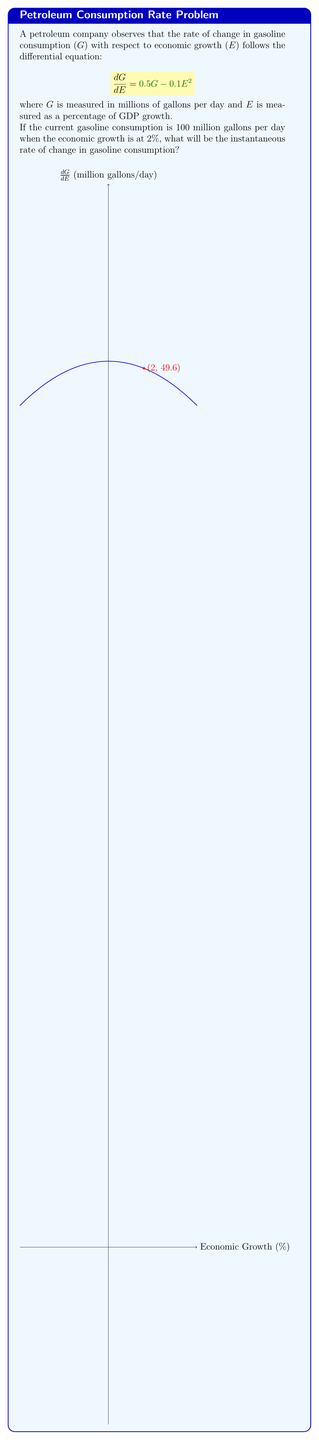Show me your answer to this math problem. To solve this problem, we need to follow these steps:

1) We are given the differential equation:
   $$\frac{dG}{dE} = 0.5G - 0.1E^2$$

2) We know that:
   G = 100 million gallons per day
   E = 2% GDP growth

3) To find the instantaneous rate of change, we need to substitute these values into the differential equation:

   $$\frac{dG}{dE} = 0.5(100) - 0.1(2^2)$$

4) Let's calculate step by step:
   
   $$\frac{dG}{dE} = 50 - 0.1(4)$$
   
   $$\frac{dG}{dE} = 50 - 0.4$$
   
   $$\frac{dG}{dE} = 49.6$$

5) Therefore, when the economic growth is at 2% and gasoline consumption is 100 million gallons per day, the instantaneous rate of change in gasoline consumption is 49.6 million gallons per day per percentage point of GDP growth.
Answer: 49.6 million gallons/day per % GDP growth 